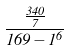Convert formula to latex. <formula><loc_0><loc_0><loc_500><loc_500>\frac { \frac { 3 4 0 } { 7 } } { 1 6 9 - 1 ^ { 6 } }</formula> 